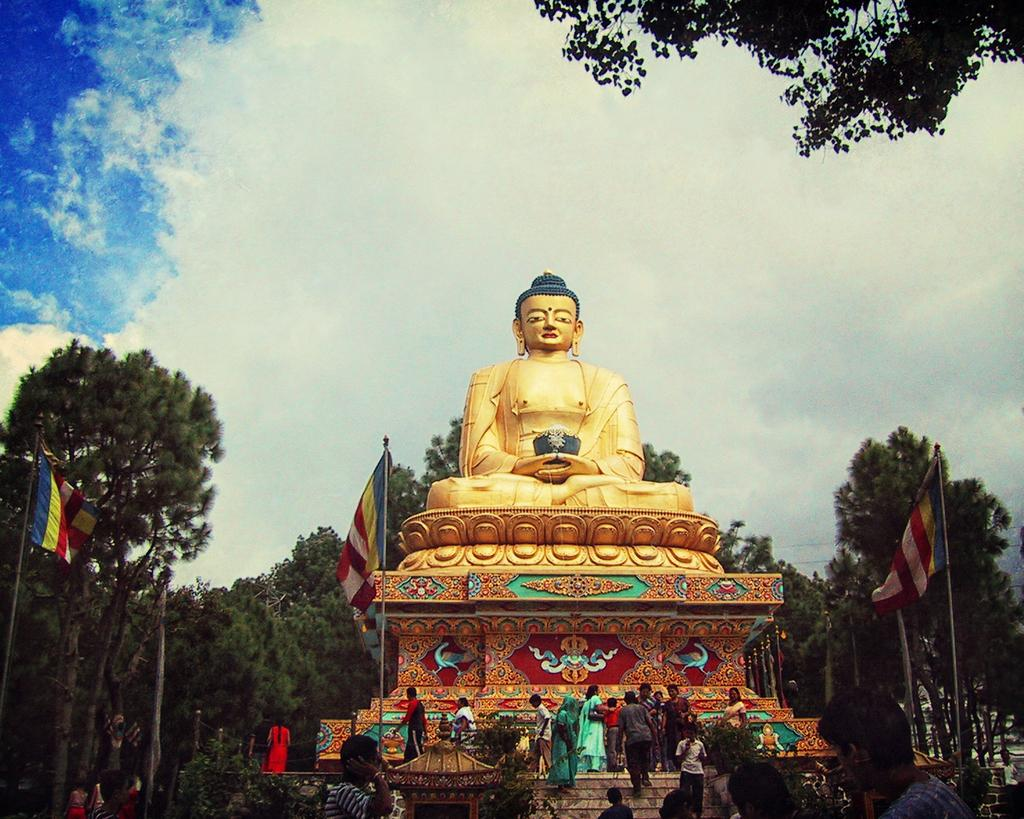What is the main subject in the image? There is a statue in the image. Are there any other people or objects in the image? Yes, there are people, stairs, flags, trees, and the sky visible in the image. What might the people be doing near the statue? It is not clear from the image what the people are doing, but they could be observing or interacting with the statue. What is the condition of the sky in the image? The sky is visible in the image, and clouds are present. Can you see any patches of grass near the statue in the image? There is no mention of grass in the provided facts, so it is not possible to determine if there are any patches of grass near the statue. Are there any chickens visible in the image? There is no mention of chickens in the provided facts, so it is not possible to determine if there are any chickens visible in the image. 